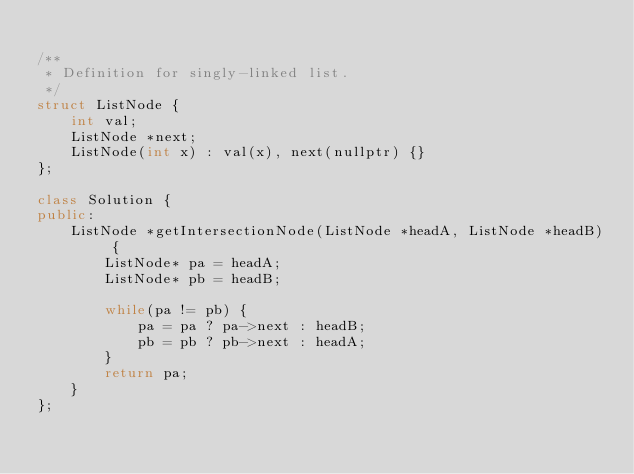Convert code to text. <code><loc_0><loc_0><loc_500><loc_500><_C++_>
/**
 * Definition for singly-linked list.
 */
struct ListNode {
    int val;
    ListNode *next;
    ListNode(int x) : val(x), next(nullptr) {}
};

class Solution {
public:
    ListNode *getIntersectionNode(ListNode *headA, ListNode *headB) {
        ListNode* pa = headA;
        ListNode* pb = headB;

        while(pa != pb) {
            pa = pa ? pa->next : headB;
            pb = pb ? pb->next : headA;
        }
        return pa;
    }
};


</code> 